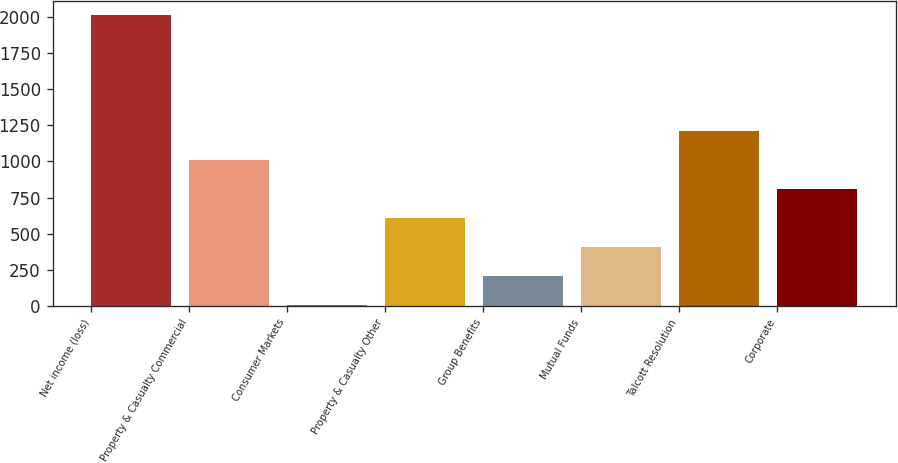Convert chart. <chart><loc_0><loc_0><loc_500><loc_500><bar_chart><fcel>Net income (loss)<fcel>Property & Casualty Commercial<fcel>Consumer Markets<fcel>Property & Casualty Other<fcel>Group Benefits<fcel>Mutual Funds<fcel>Talcott Resolution<fcel>Corporate<nl><fcel>2011<fcel>1009<fcel>7<fcel>608.2<fcel>207.4<fcel>407.8<fcel>1209.4<fcel>808.6<nl></chart> 